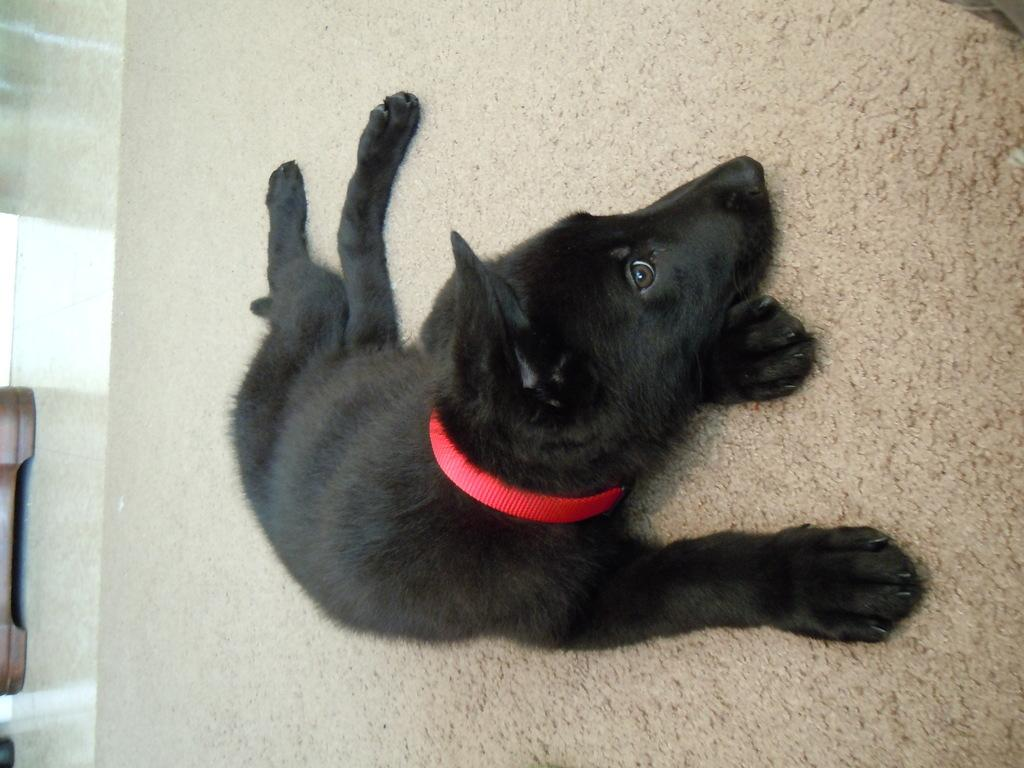What type of animal is in the image? There is a black dog in the image. Where is the dog located in the image? The dog is on the floor. How many cats are playing in the park in the image? There are no cats or park present in the image; it features a black dog on the floor. 